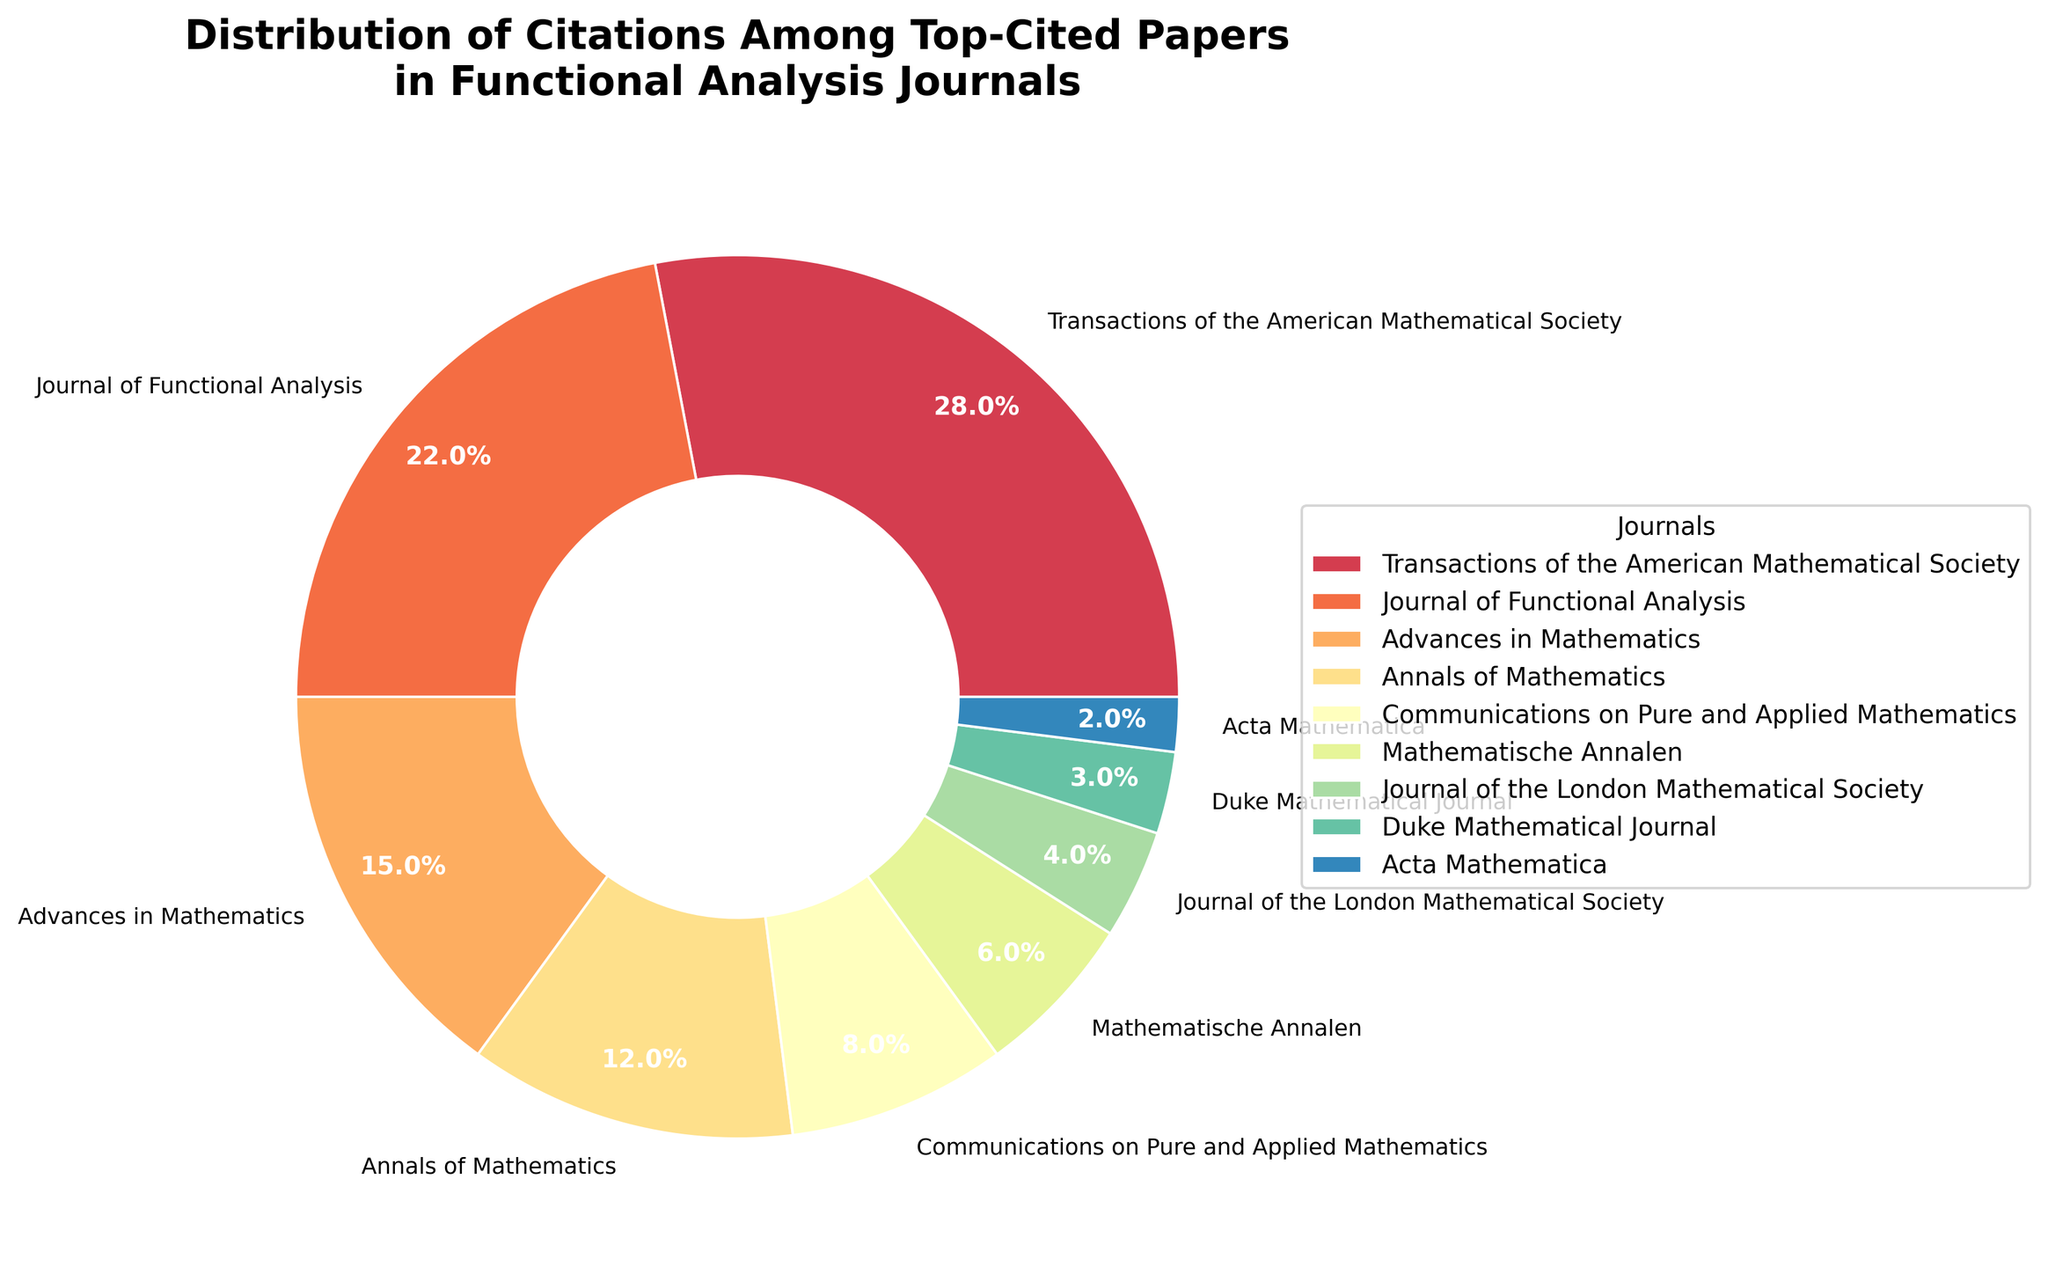What's the sum of the citations of the top two journals? The top two journals based on the legend are "Transactions of the American Mathematical Society" and "Journal of Functional Analysis". Their citation percentages are 28% and 22% respectively. The sum of these percentages is 28 + 22 = 50%
Answer: 50% Which journal has the lowest percentage of citations? By observing the legend and the segments of the pie chart, "Acta Mathematica" has the smallest segment indicating the lowest percentage of citations.
Answer: Acta Mathematica What is the difference in citation percentage between "Annals of Mathematics" and "Mathematische Annalen"? From the pie chart, "Annals of Mathematics" has 12% and "Mathematische Annalen" has 6%. The difference is 12 - 6 = 6%
Answer: 6% Which journal appears first in the legend with less than 5% citations? Reading down the legend, the first journal with less than 5% is "Journal of the London Mathematical Society" which has 4%.
Answer: Journal of the London Mathematical Society What percentage of citations do the top three journals account for? The top three journals are "Transactions of the American Mathematical Society" (28%), "Journal of Functional Analysis" (22%), and "Advances in Mathematics" (15%). Summing their percentages gives 28 + 22 + 15 = 65%
Answer: 65% Which two journals combined have close to 10% of the citations? "Communications on Pure and Applied Mathematics" has 8% and "Mathematische Annalen" has 6%. Adding them gives 8 + 6 = 14%. The closest combination below 10% is "Journal of the London Mathematical Society" (4%) and "Duke Mathematical Journal" (3%) which adds to 4 + 3 = 7%.
Answer: Journal of the London Mathematical Society and Duke Mathematical Journal How many journals have a citation percentage greater than 10%? In the legend, the journals with more than 10% citations are "Transactions of the American Mathematical Society" (28%), "Journal of Functional Analysis" (22%), "Advances in Mathematics" (15%), and "Annals of Mathematics" (12%). This sums to 4 journals.
Answer: 4 Between "Duke Mathematical Journal" and "Acta Mathematica", which has a higher percentage of citations? According to the legend and corresponding segments, "Duke Mathematical Journal" has 3% and "Acta Mathematica" has 2%. Thus, "Duke Mathematical Journal" has the higher percentage.
Answer: Duke Mathematical Journal What percentage do the bottom half of the journals (by citation percentage) account for? The bottom half includes "Communications on Pure and Applied Mathematics" (8%), "Mathematische Annalen" (6%), "Journal of the London Mathematical Society" (4%), "Duke Mathematical Journal" (3%), and "Acta Mathematica" (2%). Summing these gives 8 + 6 + 4 + 3 + 2 = 23%.
Answer: 23% What is the average percentage of citations for all journals? Summing all percentages: 28 + 22 + 15 + 12 + 8 + 6 + 4 + 3 + 2 = 100%. There are 9 journals, so the average is 100 / 9 ≈ 11.11%.
Answer: 11.11% 